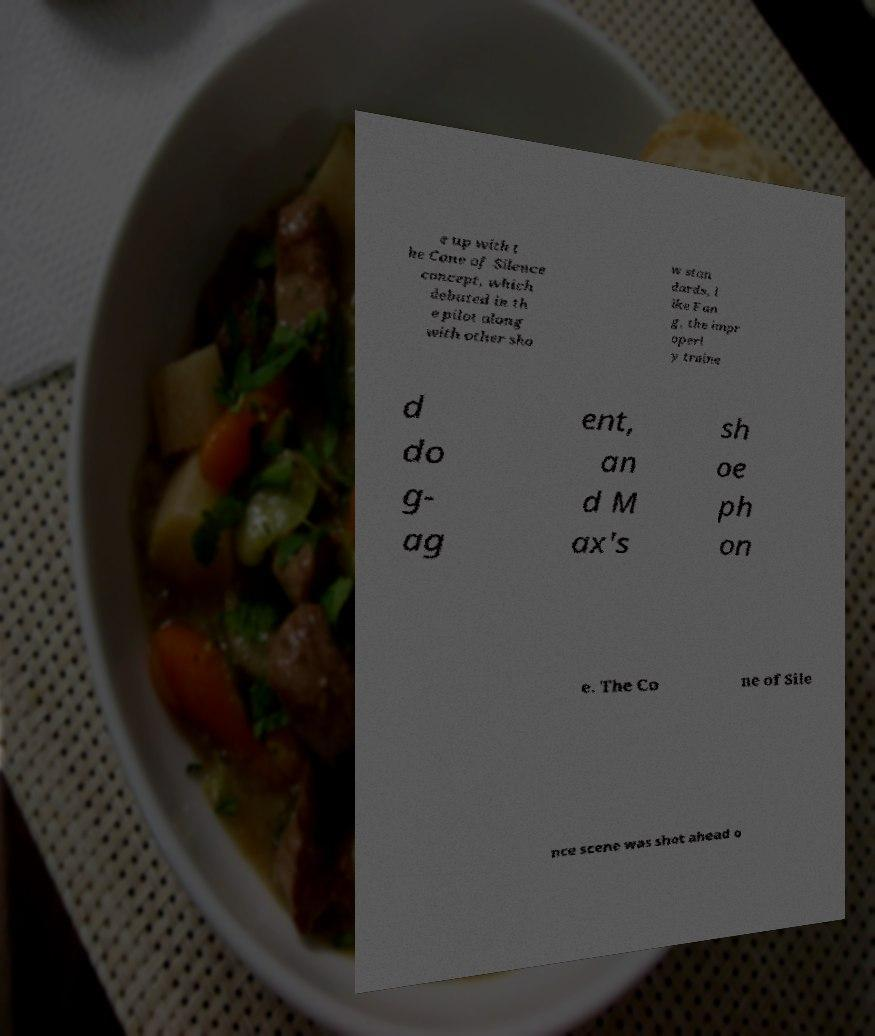For documentation purposes, I need the text within this image transcribed. Could you provide that? e up with t he Cone of Silence concept, which debuted in th e pilot along with other sho w stan dards, l ike Fan g, the impr operl y traine d do g- ag ent, an d M ax's sh oe ph on e. The Co ne of Sile nce scene was shot ahead o 